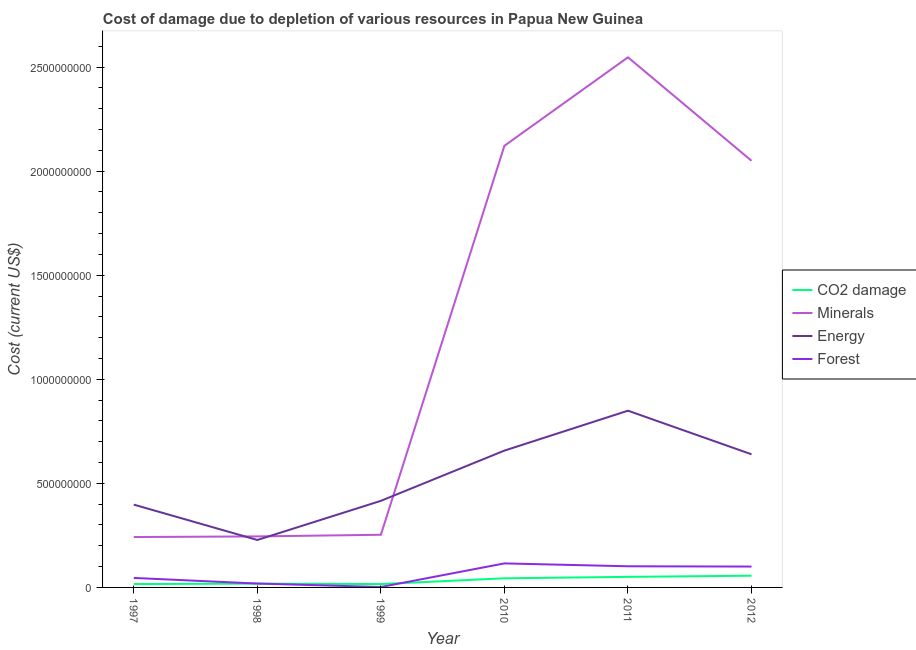How many different coloured lines are there?
Give a very brief answer. 4. What is the cost of damage due to depletion of coal in 1999?
Your answer should be compact. 1.61e+07. Across all years, what is the maximum cost of damage due to depletion of minerals?
Make the answer very short. 2.55e+09. Across all years, what is the minimum cost of damage due to depletion of energy?
Provide a succinct answer. 2.28e+08. In which year was the cost of damage due to depletion of energy minimum?
Ensure brevity in your answer.  1998. What is the total cost of damage due to depletion of energy in the graph?
Provide a short and direct response. 3.19e+09. What is the difference between the cost of damage due to depletion of energy in 1997 and that in 2010?
Keep it short and to the point. -2.60e+08. What is the difference between the cost of damage due to depletion of minerals in 1997 and the cost of damage due to depletion of forests in 2012?
Your answer should be very brief. 1.42e+08. What is the average cost of damage due to depletion of minerals per year?
Keep it short and to the point. 1.24e+09. In the year 1997, what is the difference between the cost of damage due to depletion of minerals and cost of damage due to depletion of energy?
Make the answer very short. -1.56e+08. What is the ratio of the cost of damage due to depletion of energy in 1998 to that in 2011?
Offer a terse response. 0.27. Is the cost of damage due to depletion of minerals in 1998 less than that in 2012?
Give a very brief answer. Yes. What is the difference between the highest and the second highest cost of damage due to depletion of minerals?
Your answer should be very brief. 4.25e+08. What is the difference between the highest and the lowest cost of damage due to depletion of forests?
Provide a succinct answer. 1.13e+08. Is the sum of the cost of damage due to depletion of forests in 1998 and 1999 greater than the maximum cost of damage due to depletion of coal across all years?
Give a very brief answer. No. Does the cost of damage due to depletion of coal monotonically increase over the years?
Give a very brief answer. No. How many lines are there?
Offer a very short reply. 4. What is the difference between two consecutive major ticks on the Y-axis?
Provide a succinct answer. 5.00e+08. Are the values on the major ticks of Y-axis written in scientific E-notation?
Offer a terse response. No. Does the graph contain grids?
Ensure brevity in your answer.  No. Where does the legend appear in the graph?
Your answer should be compact. Center right. What is the title of the graph?
Your answer should be very brief. Cost of damage due to depletion of various resources in Papua New Guinea . What is the label or title of the Y-axis?
Offer a very short reply. Cost (current US$). What is the Cost (current US$) in CO2 damage in 1997?
Keep it short and to the point. 1.62e+07. What is the Cost (current US$) in Minerals in 1997?
Your response must be concise. 2.42e+08. What is the Cost (current US$) of Energy in 1997?
Your answer should be very brief. 3.98e+08. What is the Cost (current US$) of Forest in 1997?
Offer a very short reply. 4.56e+07. What is the Cost (current US$) in CO2 damage in 1998?
Your answer should be very brief. 1.84e+07. What is the Cost (current US$) of Minerals in 1998?
Give a very brief answer. 2.45e+08. What is the Cost (current US$) of Energy in 1998?
Your answer should be very brief. 2.28e+08. What is the Cost (current US$) in Forest in 1998?
Offer a terse response. 1.86e+07. What is the Cost (current US$) of CO2 damage in 1999?
Provide a short and direct response. 1.61e+07. What is the Cost (current US$) of Minerals in 1999?
Give a very brief answer. 2.53e+08. What is the Cost (current US$) in Energy in 1999?
Your answer should be compact. 4.16e+08. What is the Cost (current US$) in Forest in 1999?
Keep it short and to the point. 2.04e+06. What is the Cost (current US$) in CO2 damage in 2010?
Your response must be concise. 4.38e+07. What is the Cost (current US$) in Minerals in 2010?
Keep it short and to the point. 2.12e+09. What is the Cost (current US$) in Energy in 2010?
Give a very brief answer. 6.57e+08. What is the Cost (current US$) in Forest in 2010?
Your response must be concise. 1.15e+08. What is the Cost (current US$) in CO2 damage in 2011?
Give a very brief answer. 5.07e+07. What is the Cost (current US$) in Minerals in 2011?
Your response must be concise. 2.55e+09. What is the Cost (current US$) of Energy in 2011?
Your answer should be compact. 8.49e+08. What is the Cost (current US$) in Forest in 2011?
Your response must be concise. 1.02e+08. What is the Cost (current US$) in CO2 damage in 2012?
Your answer should be very brief. 5.64e+07. What is the Cost (current US$) in Minerals in 2012?
Your response must be concise. 2.05e+09. What is the Cost (current US$) in Energy in 2012?
Provide a succinct answer. 6.40e+08. What is the Cost (current US$) of Forest in 2012?
Offer a very short reply. 1.00e+08. Across all years, what is the maximum Cost (current US$) in CO2 damage?
Give a very brief answer. 5.64e+07. Across all years, what is the maximum Cost (current US$) in Minerals?
Provide a short and direct response. 2.55e+09. Across all years, what is the maximum Cost (current US$) in Energy?
Provide a succinct answer. 8.49e+08. Across all years, what is the maximum Cost (current US$) of Forest?
Keep it short and to the point. 1.15e+08. Across all years, what is the minimum Cost (current US$) in CO2 damage?
Make the answer very short. 1.61e+07. Across all years, what is the minimum Cost (current US$) in Minerals?
Offer a very short reply. 2.42e+08. Across all years, what is the minimum Cost (current US$) of Energy?
Offer a very short reply. 2.28e+08. Across all years, what is the minimum Cost (current US$) of Forest?
Your answer should be compact. 2.04e+06. What is the total Cost (current US$) in CO2 damage in the graph?
Your response must be concise. 2.01e+08. What is the total Cost (current US$) in Minerals in the graph?
Make the answer very short. 7.46e+09. What is the total Cost (current US$) of Energy in the graph?
Give a very brief answer. 3.19e+09. What is the total Cost (current US$) of Forest in the graph?
Provide a succinct answer. 3.84e+08. What is the difference between the Cost (current US$) of CO2 damage in 1997 and that in 1998?
Ensure brevity in your answer.  -2.20e+06. What is the difference between the Cost (current US$) of Minerals in 1997 and that in 1998?
Make the answer very short. -3.05e+06. What is the difference between the Cost (current US$) of Energy in 1997 and that in 1998?
Give a very brief answer. 1.70e+08. What is the difference between the Cost (current US$) in Forest in 1997 and that in 1998?
Give a very brief answer. 2.70e+07. What is the difference between the Cost (current US$) of CO2 damage in 1997 and that in 1999?
Your answer should be very brief. 5.19e+04. What is the difference between the Cost (current US$) of Minerals in 1997 and that in 1999?
Provide a short and direct response. -1.10e+07. What is the difference between the Cost (current US$) in Energy in 1997 and that in 1999?
Offer a terse response. -1.82e+07. What is the difference between the Cost (current US$) in Forest in 1997 and that in 1999?
Your response must be concise. 4.36e+07. What is the difference between the Cost (current US$) in CO2 damage in 1997 and that in 2010?
Offer a very short reply. -2.77e+07. What is the difference between the Cost (current US$) in Minerals in 1997 and that in 2010?
Provide a succinct answer. -1.88e+09. What is the difference between the Cost (current US$) of Energy in 1997 and that in 2010?
Provide a short and direct response. -2.60e+08. What is the difference between the Cost (current US$) in Forest in 1997 and that in 2010?
Your answer should be very brief. -6.98e+07. What is the difference between the Cost (current US$) in CO2 damage in 1997 and that in 2011?
Keep it short and to the point. -3.45e+07. What is the difference between the Cost (current US$) in Minerals in 1997 and that in 2011?
Your answer should be compact. -2.30e+09. What is the difference between the Cost (current US$) of Energy in 1997 and that in 2011?
Keep it short and to the point. -4.51e+08. What is the difference between the Cost (current US$) of Forest in 1997 and that in 2011?
Offer a very short reply. -5.60e+07. What is the difference between the Cost (current US$) in CO2 damage in 1997 and that in 2012?
Ensure brevity in your answer.  -4.02e+07. What is the difference between the Cost (current US$) in Minerals in 1997 and that in 2012?
Ensure brevity in your answer.  -1.81e+09. What is the difference between the Cost (current US$) of Energy in 1997 and that in 2012?
Your response must be concise. -2.42e+08. What is the difference between the Cost (current US$) in Forest in 1997 and that in 2012?
Make the answer very short. -5.46e+07. What is the difference between the Cost (current US$) of CO2 damage in 1998 and that in 1999?
Your answer should be very brief. 2.25e+06. What is the difference between the Cost (current US$) of Minerals in 1998 and that in 1999?
Your answer should be very brief. -7.93e+06. What is the difference between the Cost (current US$) in Energy in 1998 and that in 1999?
Ensure brevity in your answer.  -1.88e+08. What is the difference between the Cost (current US$) in Forest in 1998 and that in 1999?
Provide a short and direct response. 1.66e+07. What is the difference between the Cost (current US$) in CO2 damage in 1998 and that in 2010?
Ensure brevity in your answer.  -2.55e+07. What is the difference between the Cost (current US$) in Minerals in 1998 and that in 2010?
Provide a short and direct response. -1.88e+09. What is the difference between the Cost (current US$) of Energy in 1998 and that in 2010?
Your answer should be very brief. -4.29e+08. What is the difference between the Cost (current US$) in Forest in 1998 and that in 2010?
Your response must be concise. -9.68e+07. What is the difference between the Cost (current US$) in CO2 damage in 1998 and that in 2011?
Keep it short and to the point. -3.23e+07. What is the difference between the Cost (current US$) in Minerals in 1998 and that in 2011?
Provide a short and direct response. -2.30e+09. What is the difference between the Cost (current US$) in Energy in 1998 and that in 2011?
Offer a very short reply. -6.21e+08. What is the difference between the Cost (current US$) of Forest in 1998 and that in 2011?
Your response must be concise. -8.30e+07. What is the difference between the Cost (current US$) of CO2 damage in 1998 and that in 2012?
Provide a short and direct response. -3.80e+07. What is the difference between the Cost (current US$) in Minerals in 1998 and that in 2012?
Offer a very short reply. -1.80e+09. What is the difference between the Cost (current US$) in Energy in 1998 and that in 2012?
Keep it short and to the point. -4.12e+08. What is the difference between the Cost (current US$) in Forest in 1998 and that in 2012?
Offer a terse response. -8.16e+07. What is the difference between the Cost (current US$) of CO2 damage in 1999 and that in 2010?
Provide a short and direct response. -2.77e+07. What is the difference between the Cost (current US$) of Minerals in 1999 and that in 2010?
Offer a very short reply. -1.87e+09. What is the difference between the Cost (current US$) in Energy in 1999 and that in 2010?
Offer a very short reply. -2.41e+08. What is the difference between the Cost (current US$) in Forest in 1999 and that in 2010?
Offer a very short reply. -1.13e+08. What is the difference between the Cost (current US$) in CO2 damage in 1999 and that in 2011?
Your answer should be compact. -3.46e+07. What is the difference between the Cost (current US$) of Minerals in 1999 and that in 2011?
Your answer should be very brief. -2.29e+09. What is the difference between the Cost (current US$) of Energy in 1999 and that in 2011?
Give a very brief answer. -4.33e+08. What is the difference between the Cost (current US$) in Forest in 1999 and that in 2011?
Ensure brevity in your answer.  -9.96e+07. What is the difference between the Cost (current US$) in CO2 damage in 1999 and that in 2012?
Offer a terse response. -4.03e+07. What is the difference between the Cost (current US$) of Minerals in 1999 and that in 2012?
Offer a very short reply. -1.80e+09. What is the difference between the Cost (current US$) in Energy in 1999 and that in 2012?
Offer a terse response. -2.24e+08. What is the difference between the Cost (current US$) of Forest in 1999 and that in 2012?
Your answer should be very brief. -9.82e+07. What is the difference between the Cost (current US$) of CO2 damage in 2010 and that in 2011?
Provide a succinct answer. -6.85e+06. What is the difference between the Cost (current US$) of Minerals in 2010 and that in 2011?
Your answer should be very brief. -4.25e+08. What is the difference between the Cost (current US$) of Energy in 2010 and that in 2011?
Your response must be concise. -1.92e+08. What is the difference between the Cost (current US$) of Forest in 2010 and that in 2011?
Make the answer very short. 1.38e+07. What is the difference between the Cost (current US$) of CO2 damage in 2010 and that in 2012?
Give a very brief answer. -1.25e+07. What is the difference between the Cost (current US$) in Minerals in 2010 and that in 2012?
Make the answer very short. 7.20e+07. What is the difference between the Cost (current US$) in Energy in 2010 and that in 2012?
Offer a terse response. 1.78e+07. What is the difference between the Cost (current US$) in Forest in 2010 and that in 2012?
Offer a terse response. 1.52e+07. What is the difference between the Cost (current US$) of CO2 damage in 2011 and that in 2012?
Give a very brief answer. -5.67e+06. What is the difference between the Cost (current US$) in Minerals in 2011 and that in 2012?
Your response must be concise. 4.97e+08. What is the difference between the Cost (current US$) of Energy in 2011 and that in 2012?
Make the answer very short. 2.10e+08. What is the difference between the Cost (current US$) in Forest in 2011 and that in 2012?
Offer a terse response. 1.37e+06. What is the difference between the Cost (current US$) of CO2 damage in 1997 and the Cost (current US$) of Minerals in 1998?
Provide a succinct answer. -2.29e+08. What is the difference between the Cost (current US$) of CO2 damage in 1997 and the Cost (current US$) of Energy in 1998?
Provide a succinct answer. -2.12e+08. What is the difference between the Cost (current US$) of CO2 damage in 1997 and the Cost (current US$) of Forest in 1998?
Make the answer very short. -2.46e+06. What is the difference between the Cost (current US$) in Minerals in 1997 and the Cost (current US$) in Energy in 1998?
Offer a very short reply. 1.41e+07. What is the difference between the Cost (current US$) in Minerals in 1997 and the Cost (current US$) in Forest in 1998?
Give a very brief answer. 2.23e+08. What is the difference between the Cost (current US$) of Energy in 1997 and the Cost (current US$) of Forest in 1998?
Give a very brief answer. 3.79e+08. What is the difference between the Cost (current US$) in CO2 damage in 1997 and the Cost (current US$) in Minerals in 1999?
Give a very brief answer. -2.37e+08. What is the difference between the Cost (current US$) in CO2 damage in 1997 and the Cost (current US$) in Energy in 1999?
Give a very brief answer. -4.00e+08. What is the difference between the Cost (current US$) in CO2 damage in 1997 and the Cost (current US$) in Forest in 1999?
Give a very brief answer. 1.41e+07. What is the difference between the Cost (current US$) in Minerals in 1997 and the Cost (current US$) in Energy in 1999?
Provide a succinct answer. -1.74e+08. What is the difference between the Cost (current US$) of Minerals in 1997 and the Cost (current US$) of Forest in 1999?
Offer a very short reply. 2.40e+08. What is the difference between the Cost (current US$) in Energy in 1997 and the Cost (current US$) in Forest in 1999?
Your answer should be very brief. 3.96e+08. What is the difference between the Cost (current US$) in CO2 damage in 1997 and the Cost (current US$) in Minerals in 2010?
Make the answer very short. -2.11e+09. What is the difference between the Cost (current US$) in CO2 damage in 1997 and the Cost (current US$) in Energy in 2010?
Your answer should be very brief. -6.41e+08. What is the difference between the Cost (current US$) of CO2 damage in 1997 and the Cost (current US$) of Forest in 2010?
Your answer should be very brief. -9.93e+07. What is the difference between the Cost (current US$) of Minerals in 1997 and the Cost (current US$) of Energy in 2010?
Make the answer very short. -4.15e+08. What is the difference between the Cost (current US$) in Minerals in 1997 and the Cost (current US$) in Forest in 2010?
Your answer should be compact. 1.27e+08. What is the difference between the Cost (current US$) of Energy in 1997 and the Cost (current US$) of Forest in 2010?
Your answer should be compact. 2.82e+08. What is the difference between the Cost (current US$) of CO2 damage in 1997 and the Cost (current US$) of Minerals in 2011?
Keep it short and to the point. -2.53e+09. What is the difference between the Cost (current US$) of CO2 damage in 1997 and the Cost (current US$) of Energy in 2011?
Ensure brevity in your answer.  -8.33e+08. What is the difference between the Cost (current US$) in CO2 damage in 1997 and the Cost (current US$) in Forest in 2011?
Your answer should be compact. -8.54e+07. What is the difference between the Cost (current US$) of Minerals in 1997 and the Cost (current US$) of Energy in 2011?
Give a very brief answer. -6.07e+08. What is the difference between the Cost (current US$) in Minerals in 1997 and the Cost (current US$) in Forest in 2011?
Offer a very short reply. 1.40e+08. What is the difference between the Cost (current US$) of Energy in 1997 and the Cost (current US$) of Forest in 2011?
Provide a short and direct response. 2.96e+08. What is the difference between the Cost (current US$) in CO2 damage in 1997 and the Cost (current US$) in Minerals in 2012?
Give a very brief answer. -2.03e+09. What is the difference between the Cost (current US$) in CO2 damage in 1997 and the Cost (current US$) in Energy in 2012?
Give a very brief answer. -6.23e+08. What is the difference between the Cost (current US$) in CO2 damage in 1997 and the Cost (current US$) in Forest in 2012?
Your answer should be very brief. -8.41e+07. What is the difference between the Cost (current US$) in Minerals in 1997 and the Cost (current US$) in Energy in 2012?
Ensure brevity in your answer.  -3.98e+08. What is the difference between the Cost (current US$) of Minerals in 1997 and the Cost (current US$) of Forest in 2012?
Provide a short and direct response. 1.42e+08. What is the difference between the Cost (current US$) in Energy in 1997 and the Cost (current US$) in Forest in 2012?
Offer a terse response. 2.98e+08. What is the difference between the Cost (current US$) of CO2 damage in 1998 and the Cost (current US$) of Minerals in 1999?
Make the answer very short. -2.35e+08. What is the difference between the Cost (current US$) of CO2 damage in 1998 and the Cost (current US$) of Energy in 1999?
Your answer should be very brief. -3.98e+08. What is the difference between the Cost (current US$) in CO2 damage in 1998 and the Cost (current US$) in Forest in 1999?
Offer a very short reply. 1.63e+07. What is the difference between the Cost (current US$) in Minerals in 1998 and the Cost (current US$) in Energy in 1999?
Your answer should be very brief. -1.71e+08. What is the difference between the Cost (current US$) of Minerals in 1998 and the Cost (current US$) of Forest in 1999?
Provide a short and direct response. 2.43e+08. What is the difference between the Cost (current US$) in Energy in 1998 and the Cost (current US$) in Forest in 1999?
Ensure brevity in your answer.  2.26e+08. What is the difference between the Cost (current US$) of CO2 damage in 1998 and the Cost (current US$) of Minerals in 2010?
Your answer should be very brief. -2.10e+09. What is the difference between the Cost (current US$) of CO2 damage in 1998 and the Cost (current US$) of Energy in 2010?
Provide a short and direct response. -6.39e+08. What is the difference between the Cost (current US$) of CO2 damage in 1998 and the Cost (current US$) of Forest in 2010?
Your response must be concise. -9.71e+07. What is the difference between the Cost (current US$) in Minerals in 1998 and the Cost (current US$) in Energy in 2010?
Your answer should be compact. -4.12e+08. What is the difference between the Cost (current US$) in Minerals in 1998 and the Cost (current US$) in Forest in 2010?
Keep it short and to the point. 1.30e+08. What is the difference between the Cost (current US$) in Energy in 1998 and the Cost (current US$) in Forest in 2010?
Your response must be concise. 1.13e+08. What is the difference between the Cost (current US$) of CO2 damage in 1998 and the Cost (current US$) of Minerals in 2011?
Provide a short and direct response. -2.53e+09. What is the difference between the Cost (current US$) of CO2 damage in 1998 and the Cost (current US$) of Energy in 2011?
Keep it short and to the point. -8.31e+08. What is the difference between the Cost (current US$) of CO2 damage in 1998 and the Cost (current US$) of Forest in 2011?
Ensure brevity in your answer.  -8.32e+07. What is the difference between the Cost (current US$) in Minerals in 1998 and the Cost (current US$) in Energy in 2011?
Provide a short and direct response. -6.04e+08. What is the difference between the Cost (current US$) in Minerals in 1998 and the Cost (current US$) in Forest in 2011?
Provide a short and direct response. 1.44e+08. What is the difference between the Cost (current US$) in Energy in 1998 and the Cost (current US$) in Forest in 2011?
Your answer should be compact. 1.26e+08. What is the difference between the Cost (current US$) of CO2 damage in 1998 and the Cost (current US$) of Minerals in 2012?
Provide a succinct answer. -2.03e+09. What is the difference between the Cost (current US$) of CO2 damage in 1998 and the Cost (current US$) of Energy in 2012?
Your answer should be compact. -6.21e+08. What is the difference between the Cost (current US$) in CO2 damage in 1998 and the Cost (current US$) in Forest in 2012?
Your answer should be very brief. -8.19e+07. What is the difference between the Cost (current US$) of Minerals in 1998 and the Cost (current US$) of Energy in 2012?
Provide a short and direct response. -3.95e+08. What is the difference between the Cost (current US$) in Minerals in 1998 and the Cost (current US$) in Forest in 2012?
Your response must be concise. 1.45e+08. What is the difference between the Cost (current US$) in Energy in 1998 and the Cost (current US$) in Forest in 2012?
Provide a succinct answer. 1.28e+08. What is the difference between the Cost (current US$) in CO2 damage in 1999 and the Cost (current US$) in Minerals in 2010?
Make the answer very short. -2.11e+09. What is the difference between the Cost (current US$) of CO2 damage in 1999 and the Cost (current US$) of Energy in 2010?
Give a very brief answer. -6.41e+08. What is the difference between the Cost (current US$) in CO2 damage in 1999 and the Cost (current US$) in Forest in 2010?
Ensure brevity in your answer.  -9.93e+07. What is the difference between the Cost (current US$) of Minerals in 1999 and the Cost (current US$) of Energy in 2010?
Your response must be concise. -4.04e+08. What is the difference between the Cost (current US$) in Minerals in 1999 and the Cost (current US$) in Forest in 2010?
Keep it short and to the point. 1.38e+08. What is the difference between the Cost (current US$) in Energy in 1999 and the Cost (current US$) in Forest in 2010?
Offer a terse response. 3.01e+08. What is the difference between the Cost (current US$) of CO2 damage in 1999 and the Cost (current US$) of Minerals in 2011?
Provide a short and direct response. -2.53e+09. What is the difference between the Cost (current US$) of CO2 damage in 1999 and the Cost (current US$) of Energy in 2011?
Provide a short and direct response. -8.33e+08. What is the difference between the Cost (current US$) in CO2 damage in 1999 and the Cost (current US$) in Forest in 2011?
Ensure brevity in your answer.  -8.55e+07. What is the difference between the Cost (current US$) in Minerals in 1999 and the Cost (current US$) in Energy in 2011?
Provide a succinct answer. -5.96e+08. What is the difference between the Cost (current US$) of Minerals in 1999 and the Cost (current US$) of Forest in 2011?
Your answer should be very brief. 1.51e+08. What is the difference between the Cost (current US$) of Energy in 1999 and the Cost (current US$) of Forest in 2011?
Make the answer very short. 3.14e+08. What is the difference between the Cost (current US$) of CO2 damage in 1999 and the Cost (current US$) of Minerals in 2012?
Your response must be concise. -2.03e+09. What is the difference between the Cost (current US$) in CO2 damage in 1999 and the Cost (current US$) in Energy in 2012?
Your response must be concise. -6.24e+08. What is the difference between the Cost (current US$) in CO2 damage in 1999 and the Cost (current US$) in Forest in 2012?
Your response must be concise. -8.41e+07. What is the difference between the Cost (current US$) of Minerals in 1999 and the Cost (current US$) of Energy in 2012?
Give a very brief answer. -3.87e+08. What is the difference between the Cost (current US$) in Minerals in 1999 and the Cost (current US$) in Forest in 2012?
Offer a terse response. 1.53e+08. What is the difference between the Cost (current US$) of Energy in 1999 and the Cost (current US$) of Forest in 2012?
Your answer should be very brief. 3.16e+08. What is the difference between the Cost (current US$) of CO2 damage in 2010 and the Cost (current US$) of Minerals in 2011?
Your response must be concise. -2.50e+09. What is the difference between the Cost (current US$) of CO2 damage in 2010 and the Cost (current US$) of Energy in 2011?
Make the answer very short. -8.05e+08. What is the difference between the Cost (current US$) of CO2 damage in 2010 and the Cost (current US$) of Forest in 2011?
Your answer should be compact. -5.78e+07. What is the difference between the Cost (current US$) in Minerals in 2010 and the Cost (current US$) in Energy in 2011?
Provide a short and direct response. 1.27e+09. What is the difference between the Cost (current US$) in Minerals in 2010 and the Cost (current US$) in Forest in 2011?
Your answer should be compact. 2.02e+09. What is the difference between the Cost (current US$) of Energy in 2010 and the Cost (current US$) of Forest in 2011?
Your response must be concise. 5.56e+08. What is the difference between the Cost (current US$) of CO2 damage in 2010 and the Cost (current US$) of Minerals in 2012?
Provide a short and direct response. -2.01e+09. What is the difference between the Cost (current US$) of CO2 damage in 2010 and the Cost (current US$) of Energy in 2012?
Provide a short and direct response. -5.96e+08. What is the difference between the Cost (current US$) of CO2 damage in 2010 and the Cost (current US$) of Forest in 2012?
Offer a terse response. -5.64e+07. What is the difference between the Cost (current US$) of Minerals in 2010 and the Cost (current US$) of Energy in 2012?
Make the answer very short. 1.48e+09. What is the difference between the Cost (current US$) in Minerals in 2010 and the Cost (current US$) in Forest in 2012?
Your response must be concise. 2.02e+09. What is the difference between the Cost (current US$) in Energy in 2010 and the Cost (current US$) in Forest in 2012?
Give a very brief answer. 5.57e+08. What is the difference between the Cost (current US$) in CO2 damage in 2011 and the Cost (current US$) in Minerals in 2012?
Keep it short and to the point. -2.00e+09. What is the difference between the Cost (current US$) of CO2 damage in 2011 and the Cost (current US$) of Energy in 2012?
Provide a short and direct response. -5.89e+08. What is the difference between the Cost (current US$) of CO2 damage in 2011 and the Cost (current US$) of Forest in 2012?
Your answer should be compact. -4.95e+07. What is the difference between the Cost (current US$) of Minerals in 2011 and the Cost (current US$) of Energy in 2012?
Offer a very short reply. 1.91e+09. What is the difference between the Cost (current US$) of Minerals in 2011 and the Cost (current US$) of Forest in 2012?
Your answer should be very brief. 2.45e+09. What is the difference between the Cost (current US$) of Energy in 2011 and the Cost (current US$) of Forest in 2012?
Make the answer very short. 7.49e+08. What is the average Cost (current US$) in CO2 damage per year?
Make the answer very short. 3.36e+07. What is the average Cost (current US$) in Minerals per year?
Your answer should be very brief. 1.24e+09. What is the average Cost (current US$) in Energy per year?
Keep it short and to the point. 5.31e+08. What is the average Cost (current US$) of Forest per year?
Your answer should be compact. 6.39e+07. In the year 1997, what is the difference between the Cost (current US$) of CO2 damage and Cost (current US$) of Minerals?
Provide a succinct answer. -2.26e+08. In the year 1997, what is the difference between the Cost (current US$) of CO2 damage and Cost (current US$) of Energy?
Keep it short and to the point. -3.82e+08. In the year 1997, what is the difference between the Cost (current US$) in CO2 damage and Cost (current US$) in Forest?
Your answer should be very brief. -2.95e+07. In the year 1997, what is the difference between the Cost (current US$) in Minerals and Cost (current US$) in Energy?
Keep it short and to the point. -1.56e+08. In the year 1997, what is the difference between the Cost (current US$) in Minerals and Cost (current US$) in Forest?
Ensure brevity in your answer.  1.96e+08. In the year 1997, what is the difference between the Cost (current US$) of Energy and Cost (current US$) of Forest?
Your response must be concise. 3.52e+08. In the year 1998, what is the difference between the Cost (current US$) of CO2 damage and Cost (current US$) of Minerals?
Make the answer very short. -2.27e+08. In the year 1998, what is the difference between the Cost (current US$) in CO2 damage and Cost (current US$) in Energy?
Offer a terse response. -2.10e+08. In the year 1998, what is the difference between the Cost (current US$) of CO2 damage and Cost (current US$) of Forest?
Your answer should be compact. -2.61e+05. In the year 1998, what is the difference between the Cost (current US$) in Minerals and Cost (current US$) in Energy?
Offer a very short reply. 1.71e+07. In the year 1998, what is the difference between the Cost (current US$) of Minerals and Cost (current US$) of Forest?
Provide a succinct answer. 2.26e+08. In the year 1998, what is the difference between the Cost (current US$) in Energy and Cost (current US$) in Forest?
Offer a terse response. 2.09e+08. In the year 1999, what is the difference between the Cost (current US$) in CO2 damage and Cost (current US$) in Minerals?
Keep it short and to the point. -2.37e+08. In the year 1999, what is the difference between the Cost (current US$) in CO2 damage and Cost (current US$) in Energy?
Your response must be concise. -4.00e+08. In the year 1999, what is the difference between the Cost (current US$) in CO2 damage and Cost (current US$) in Forest?
Offer a terse response. 1.41e+07. In the year 1999, what is the difference between the Cost (current US$) in Minerals and Cost (current US$) in Energy?
Ensure brevity in your answer.  -1.63e+08. In the year 1999, what is the difference between the Cost (current US$) in Minerals and Cost (current US$) in Forest?
Ensure brevity in your answer.  2.51e+08. In the year 1999, what is the difference between the Cost (current US$) in Energy and Cost (current US$) in Forest?
Provide a short and direct response. 4.14e+08. In the year 2010, what is the difference between the Cost (current US$) of CO2 damage and Cost (current US$) of Minerals?
Keep it short and to the point. -2.08e+09. In the year 2010, what is the difference between the Cost (current US$) in CO2 damage and Cost (current US$) in Energy?
Your response must be concise. -6.14e+08. In the year 2010, what is the difference between the Cost (current US$) in CO2 damage and Cost (current US$) in Forest?
Provide a short and direct response. -7.16e+07. In the year 2010, what is the difference between the Cost (current US$) of Minerals and Cost (current US$) of Energy?
Ensure brevity in your answer.  1.46e+09. In the year 2010, what is the difference between the Cost (current US$) of Minerals and Cost (current US$) of Forest?
Ensure brevity in your answer.  2.01e+09. In the year 2010, what is the difference between the Cost (current US$) of Energy and Cost (current US$) of Forest?
Make the answer very short. 5.42e+08. In the year 2011, what is the difference between the Cost (current US$) of CO2 damage and Cost (current US$) of Minerals?
Ensure brevity in your answer.  -2.50e+09. In the year 2011, what is the difference between the Cost (current US$) in CO2 damage and Cost (current US$) in Energy?
Offer a very short reply. -7.98e+08. In the year 2011, what is the difference between the Cost (current US$) in CO2 damage and Cost (current US$) in Forest?
Provide a succinct answer. -5.09e+07. In the year 2011, what is the difference between the Cost (current US$) of Minerals and Cost (current US$) of Energy?
Your answer should be compact. 1.70e+09. In the year 2011, what is the difference between the Cost (current US$) of Minerals and Cost (current US$) of Forest?
Your response must be concise. 2.45e+09. In the year 2011, what is the difference between the Cost (current US$) in Energy and Cost (current US$) in Forest?
Your response must be concise. 7.48e+08. In the year 2012, what is the difference between the Cost (current US$) in CO2 damage and Cost (current US$) in Minerals?
Your answer should be very brief. -1.99e+09. In the year 2012, what is the difference between the Cost (current US$) of CO2 damage and Cost (current US$) of Energy?
Provide a short and direct response. -5.83e+08. In the year 2012, what is the difference between the Cost (current US$) in CO2 damage and Cost (current US$) in Forest?
Keep it short and to the point. -4.39e+07. In the year 2012, what is the difference between the Cost (current US$) of Minerals and Cost (current US$) of Energy?
Make the answer very short. 1.41e+09. In the year 2012, what is the difference between the Cost (current US$) of Minerals and Cost (current US$) of Forest?
Your response must be concise. 1.95e+09. In the year 2012, what is the difference between the Cost (current US$) of Energy and Cost (current US$) of Forest?
Your answer should be compact. 5.39e+08. What is the ratio of the Cost (current US$) of CO2 damage in 1997 to that in 1998?
Your answer should be very brief. 0.88. What is the ratio of the Cost (current US$) of Minerals in 1997 to that in 1998?
Make the answer very short. 0.99. What is the ratio of the Cost (current US$) in Energy in 1997 to that in 1998?
Offer a terse response. 1.75. What is the ratio of the Cost (current US$) of Forest in 1997 to that in 1998?
Ensure brevity in your answer.  2.45. What is the ratio of the Cost (current US$) in CO2 damage in 1997 to that in 1999?
Make the answer very short. 1. What is the ratio of the Cost (current US$) in Minerals in 1997 to that in 1999?
Your answer should be compact. 0.96. What is the ratio of the Cost (current US$) of Energy in 1997 to that in 1999?
Your answer should be compact. 0.96. What is the ratio of the Cost (current US$) of Forest in 1997 to that in 1999?
Your answer should be very brief. 22.35. What is the ratio of the Cost (current US$) in CO2 damage in 1997 to that in 2010?
Provide a short and direct response. 0.37. What is the ratio of the Cost (current US$) in Minerals in 1997 to that in 2010?
Offer a terse response. 0.11. What is the ratio of the Cost (current US$) in Energy in 1997 to that in 2010?
Your answer should be very brief. 0.61. What is the ratio of the Cost (current US$) in Forest in 1997 to that in 2010?
Your response must be concise. 0.4. What is the ratio of the Cost (current US$) of CO2 damage in 1997 to that in 2011?
Offer a very short reply. 0.32. What is the ratio of the Cost (current US$) of Minerals in 1997 to that in 2011?
Make the answer very short. 0.1. What is the ratio of the Cost (current US$) in Energy in 1997 to that in 2011?
Offer a terse response. 0.47. What is the ratio of the Cost (current US$) in Forest in 1997 to that in 2011?
Provide a succinct answer. 0.45. What is the ratio of the Cost (current US$) in CO2 damage in 1997 to that in 2012?
Your answer should be compact. 0.29. What is the ratio of the Cost (current US$) in Minerals in 1997 to that in 2012?
Provide a succinct answer. 0.12. What is the ratio of the Cost (current US$) of Energy in 1997 to that in 2012?
Provide a succinct answer. 0.62. What is the ratio of the Cost (current US$) in Forest in 1997 to that in 2012?
Keep it short and to the point. 0.46. What is the ratio of the Cost (current US$) of CO2 damage in 1998 to that in 1999?
Ensure brevity in your answer.  1.14. What is the ratio of the Cost (current US$) of Minerals in 1998 to that in 1999?
Your response must be concise. 0.97. What is the ratio of the Cost (current US$) of Energy in 1998 to that in 1999?
Offer a very short reply. 0.55. What is the ratio of the Cost (current US$) in Forest in 1998 to that in 1999?
Your answer should be compact. 9.12. What is the ratio of the Cost (current US$) of CO2 damage in 1998 to that in 2010?
Offer a terse response. 0.42. What is the ratio of the Cost (current US$) in Minerals in 1998 to that in 2010?
Give a very brief answer. 0.12. What is the ratio of the Cost (current US$) of Energy in 1998 to that in 2010?
Provide a short and direct response. 0.35. What is the ratio of the Cost (current US$) of Forest in 1998 to that in 2010?
Offer a terse response. 0.16. What is the ratio of the Cost (current US$) in CO2 damage in 1998 to that in 2011?
Keep it short and to the point. 0.36. What is the ratio of the Cost (current US$) in Minerals in 1998 to that in 2011?
Make the answer very short. 0.1. What is the ratio of the Cost (current US$) of Energy in 1998 to that in 2011?
Your answer should be compact. 0.27. What is the ratio of the Cost (current US$) of Forest in 1998 to that in 2011?
Ensure brevity in your answer.  0.18. What is the ratio of the Cost (current US$) of CO2 damage in 1998 to that in 2012?
Offer a very short reply. 0.33. What is the ratio of the Cost (current US$) of Minerals in 1998 to that in 2012?
Your answer should be very brief. 0.12. What is the ratio of the Cost (current US$) of Energy in 1998 to that in 2012?
Keep it short and to the point. 0.36. What is the ratio of the Cost (current US$) of Forest in 1998 to that in 2012?
Give a very brief answer. 0.19. What is the ratio of the Cost (current US$) of CO2 damage in 1999 to that in 2010?
Make the answer very short. 0.37. What is the ratio of the Cost (current US$) in Minerals in 1999 to that in 2010?
Keep it short and to the point. 0.12. What is the ratio of the Cost (current US$) in Energy in 1999 to that in 2010?
Your answer should be very brief. 0.63. What is the ratio of the Cost (current US$) of Forest in 1999 to that in 2010?
Keep it short and to the point. 0.02. What is the ratio of the Cost (current US$) in CO2 damage in 1999 to that in 2011?
Make the answer very short. 0.32. What is the ratio of the Cost (current US$) in Minerals in 1999 to that in 2011?
Keep it short and to the point. 0.1. What is the ratio of the Cost (current US$) of Energy in 1999 to that in 2011?
Offer a very short reply. 0.49. What is the ratio of the Cost (current US$) of Forest in 1999 to that in 2011?
Your answer should be very brief. 0.02. What is the ratio of the Cost (current US$) in CO2 damage in 1999 to that in 2012?
Offer a very short reply. 0.29. What is the ratio of the Cost (current US$) of Minerals in 1999 to that in 2012?
Your response must be concise. 0.12. What is the ratio of the Cost (current US$) of Energy in 1999 to that in 2012?
Your answer should be very brief. 0.65. What is the ratio of the Cost (current US$) in Forest in 1999 to that in 2012?
Your answer should be compact. 0.02. What is the ratio of the Cost (current US$) of CO2 damage in 2010 to that in 2011?
Give a very brief answer. 0.86. What is the ratio of the Cost (current US$) of Minerals in 2010 to that in 2011?
Your answer should be compact. 0.83. What is the ratio of the Cost (current US$) in Energy in 2010 to that in 2011?
Your answer should be compact. 0.77. What is the ratio of the Cost (current US$) of Forest in 2010 to that in 2011?
Make the answer very short. 1.14. What is the ratio of the Cost (current US$) in CO2 damage in 2010 to that in 2012?
Your answer should be compact. 0.78. What is the ratio of the Cost (current US$) in Minerals in 2010 to that in 2012?
Ensure brevity in your answer.  1.04. What is the ratio of the Cost (current US$) in Energy in 2010 to that in 2012?
Offer a terse response. 1.03. What is the ratio of the Cost (current US$) in Forest in 2010 to that in 2012?
Your response must be concise. 1.15. What is the ratio of the Cost (current US$) of CO2 damage in 2011 to that in 2012?
Provide a short and direct response. 0.9. What is the ratio of the Cost (current US$) in Minerals in 2011 to that in 2012?
Offer a terse response. 1.24. What is the ratio of the Cost (current US$) of Energy in 2011 to that in 2012?
Keep it short and to the point. 1.33. What is the ratio of the Cost (current US$) of Forest in 2011 to that in 2012?
Your answer should be compact. 1.01. What is the difference between the highest and the second highest Cost (current US$) in CO2 damage?
Your response must be concise. 5.67e+06. What is the difference between the highest and the second highest Cost (current US$) in Minerals?
Your answer should be very brief. 4.25e+08. What is the difference between the highest and the second highest Cost (current US$) of Energy?
Your answer should be compact. 1.92e+08. What is the difference between the highest and the second highest Cost (current US$) in Forest?
Keep it short and to the point. 1.38e+07. What is the difference between the highest and the lowest Cost (current US$) of CO2 damage?
Your answer should be very brief. 4.03e+07. What is the difference between the highest and the lowest Cost (current US$) of Minerals?
Give a very brief answer. 2.30e+09. What is the difference between the highest and the lowest Cost (current US$) of Energy?
Ensure brevity in your answer.  6.21e+08. What is the difference between the highest and the lowest Cost (current US$) in Forest?
Give a very brief answer. 1.13e+08. 